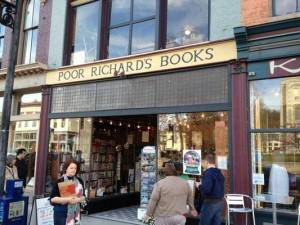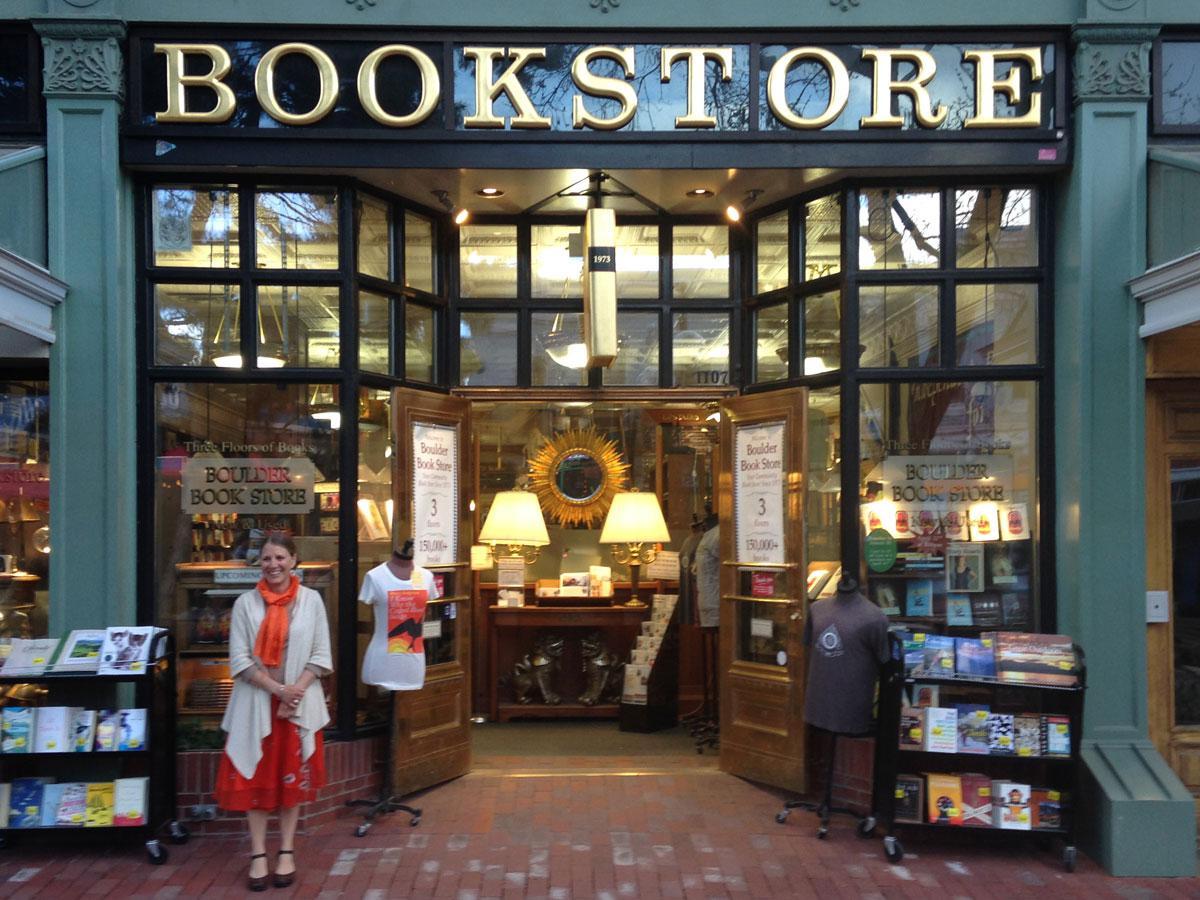The first image is the image on the left, the second image is the image on the right. Evaluate the accuracy of this statement regarding the images: "An image shows at least two people walking past a shop.". Is it true? Answer yes or no. Yes. 